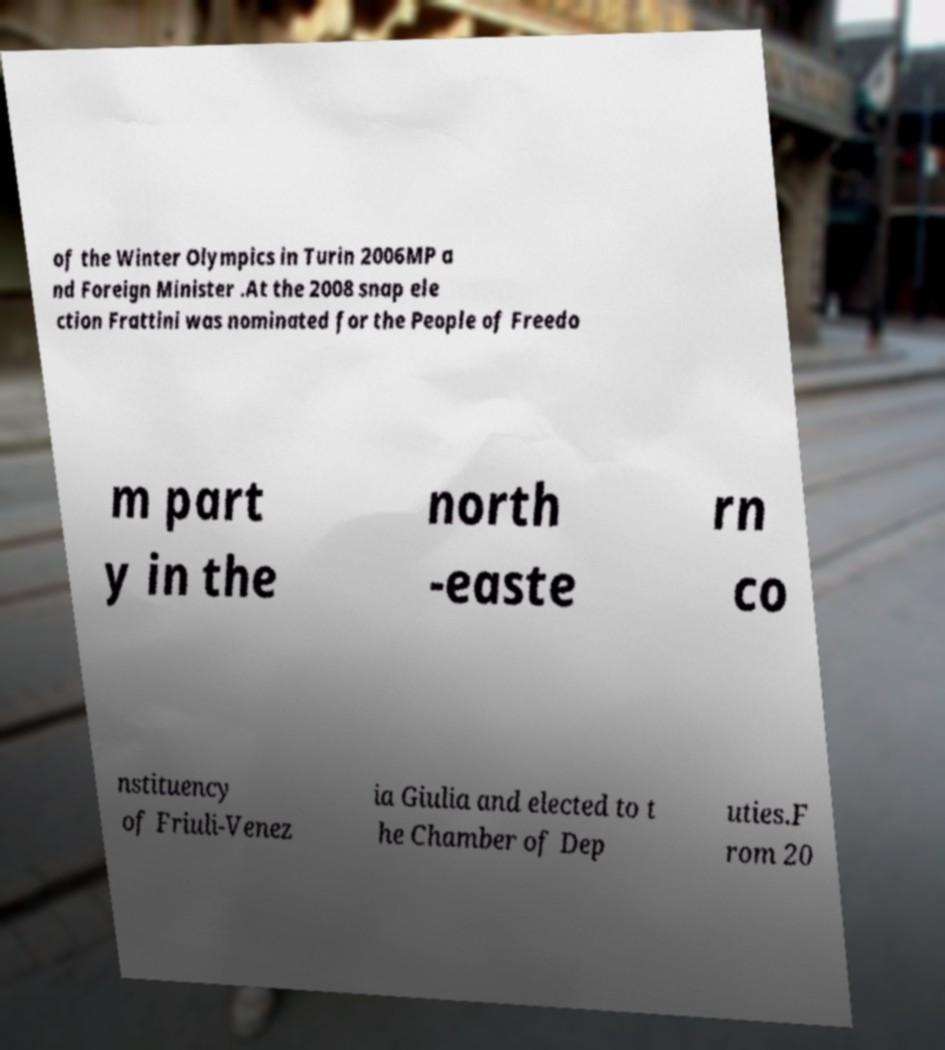Can you read and provide the text displayed in the image?This photo seems to have some interesting text. Can you extract and type it out for me? of the Winter Olympics in Turin 2006MP a nd Foreign Minister .At the 2008 snap ele ction Frattini was nominated for the People of Freedo m part y in the north -easte rn co nstituency of Friuli-Venez ia Giulia and elected to t he Chamber of Dep uties.F rom 20 